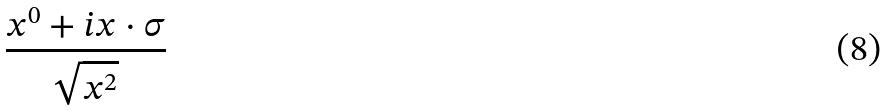Convert formula to latex. <formula><loc_0><loc_0><loc_500><loc_500>\frac { x ^ { 0 } + i x \cdot \sigma } { \sqrt { x ^ { 2 } } }</formula> 